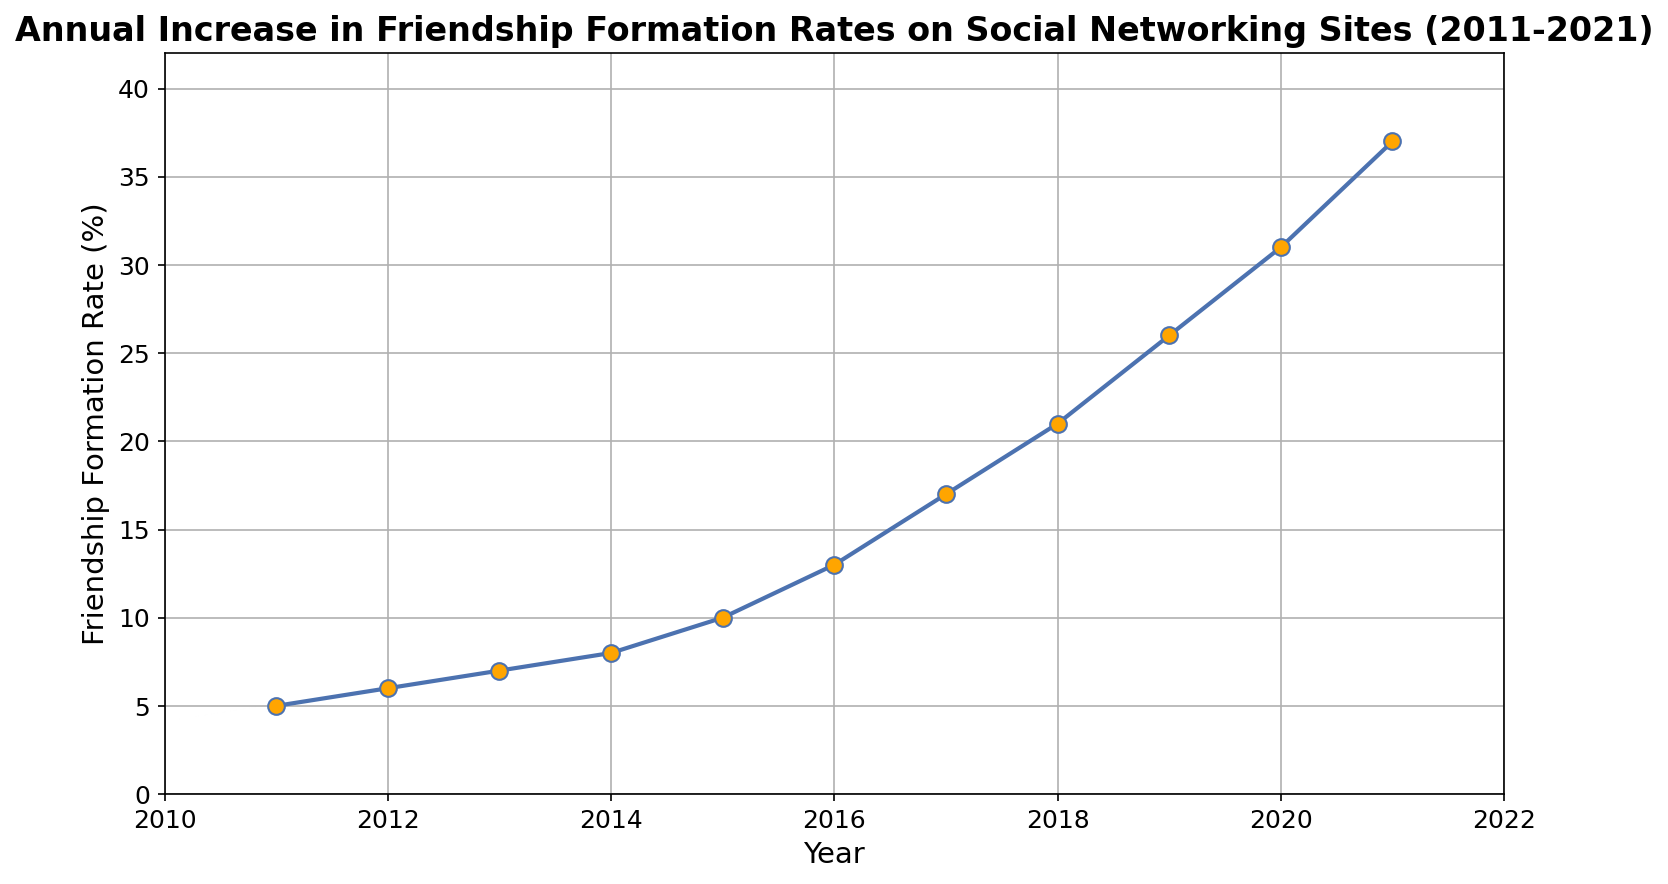What was the friendship formation rate in 2015? The figure shows the friendship formation rate on the y-axis and the years on the x-axis. Locate the year 2015 and read the corresponding rate.
Answer: 10% Between which two consecutive years did the friendship formation rate experience the highest increase? Identify the rates for each year and calculate the differences between consecutive years to find the largest increase. The highest change occurred between 2020 and 2021, as the rate went from 31% to 37%.
Answer: 2020 and 2021 By how much did the friendship formation rate increase from 2011 to 2021? Subtract the rate in 2011 from the rate in 2021. In 2011 it was 5%, and in 2021 it was 37%, so the increase is 37 - 5.
Answer: 32% What is the average friendship formation rate from 2011 to 2021? Sum the rates from 2011 to 2021 and divide by the number of years. The sum is 181 and there are 11 years. 181 / 11 = 16.45.
Answer: 16.45% What was the rate of increase in friendship formation between 2017 and 2018? Subtract the rate in 2017 from the rate in 2018. In 2017 it was 17%, and in 2018 it was 21%. The increase is 21 - 17.
Answer: 4% In which year does the rate first reach double digits? Locate the point where the rate first reaches 10% or more by scanning from left to right along the x-axis. The rate reaches 10% in 2015.
Answer: 2015 How many times did the rate increase by exactly 1% year over year? Compare the rates for each consecutive pair of years and count how many times the difference is exactly 1%. This occurs once, between 2011 and 2012.
Answer: 1 time What is the trend in the friendship formation rates from 2011 to 2021 as shown in the chart? Observe the chart to determine whether the rates are increasing, decreasing, or staying constant. The trend shows a consistent increase over the years.
Answer: Increasing In which year was the rate closest to 20%? Identify the year where the formation rate is nearest to 20% by observing the y-axis values. The closest rate is 21% in 2018.
Answer: 2018 What was the cumulative increase in friendship formation rates from 2016 to 2020? Calculate the change for each consecutive year between 2016 and 2020 and sum these increases. The increases are: (2017-2016 = 4), (2018-2017 = 4), (2019-2018 = 5), (2020-2019 = 5). The total is 4 + 4 + 5 + 5 = 18.
Answer: 18% 